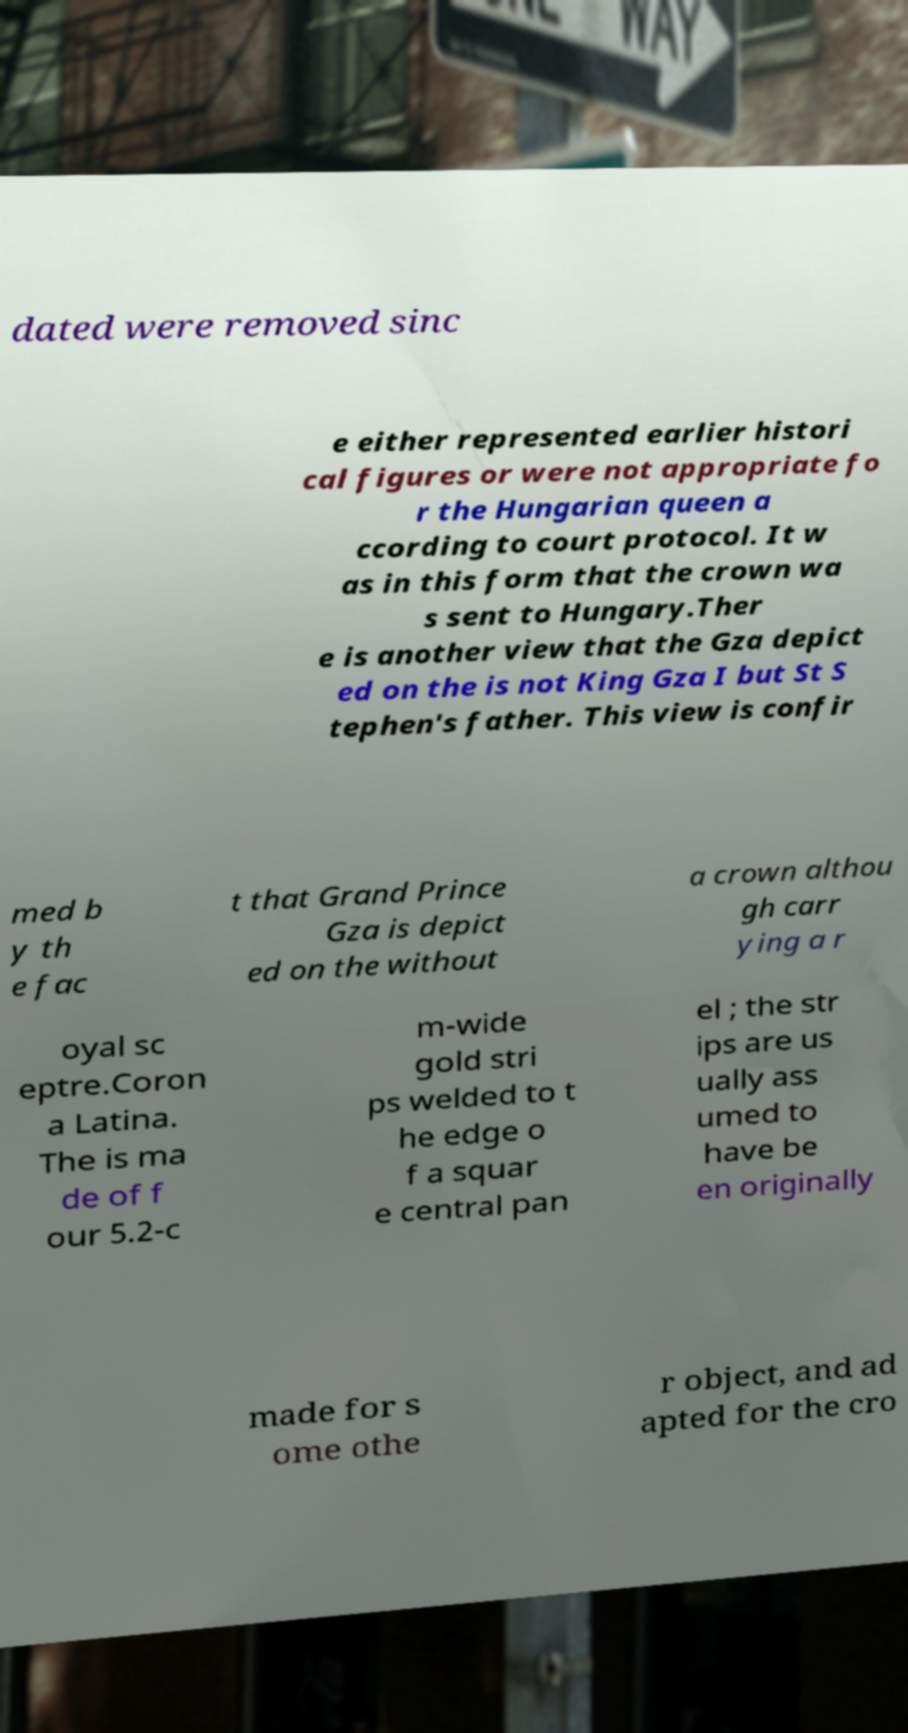Could you assist in decoding the text presented in this image and type it out clearly? dated were removed sinc e either represented earlier histori cal figures or were not appropriate fo r the Hungarian queen a ccording to court protocol. It w as in this form that the crown wa s sent to Hungary.Ther e is another view that the Gza depict ed on the is not King Gza I but St S tephen's father. This view is confir med b y th e fac t that Grand Prince Gza is depict ed on the without a crown althou gh carr ying a r oyal sc eptre.Coron a Latina. The is ma de of f our 5.2-c m-wide gold stri ps welded to t he edge o f a squar e central pan el ; the str ips are us ually ass umed to have be en originally made for s ome othe r object, and ad apted for the cro 